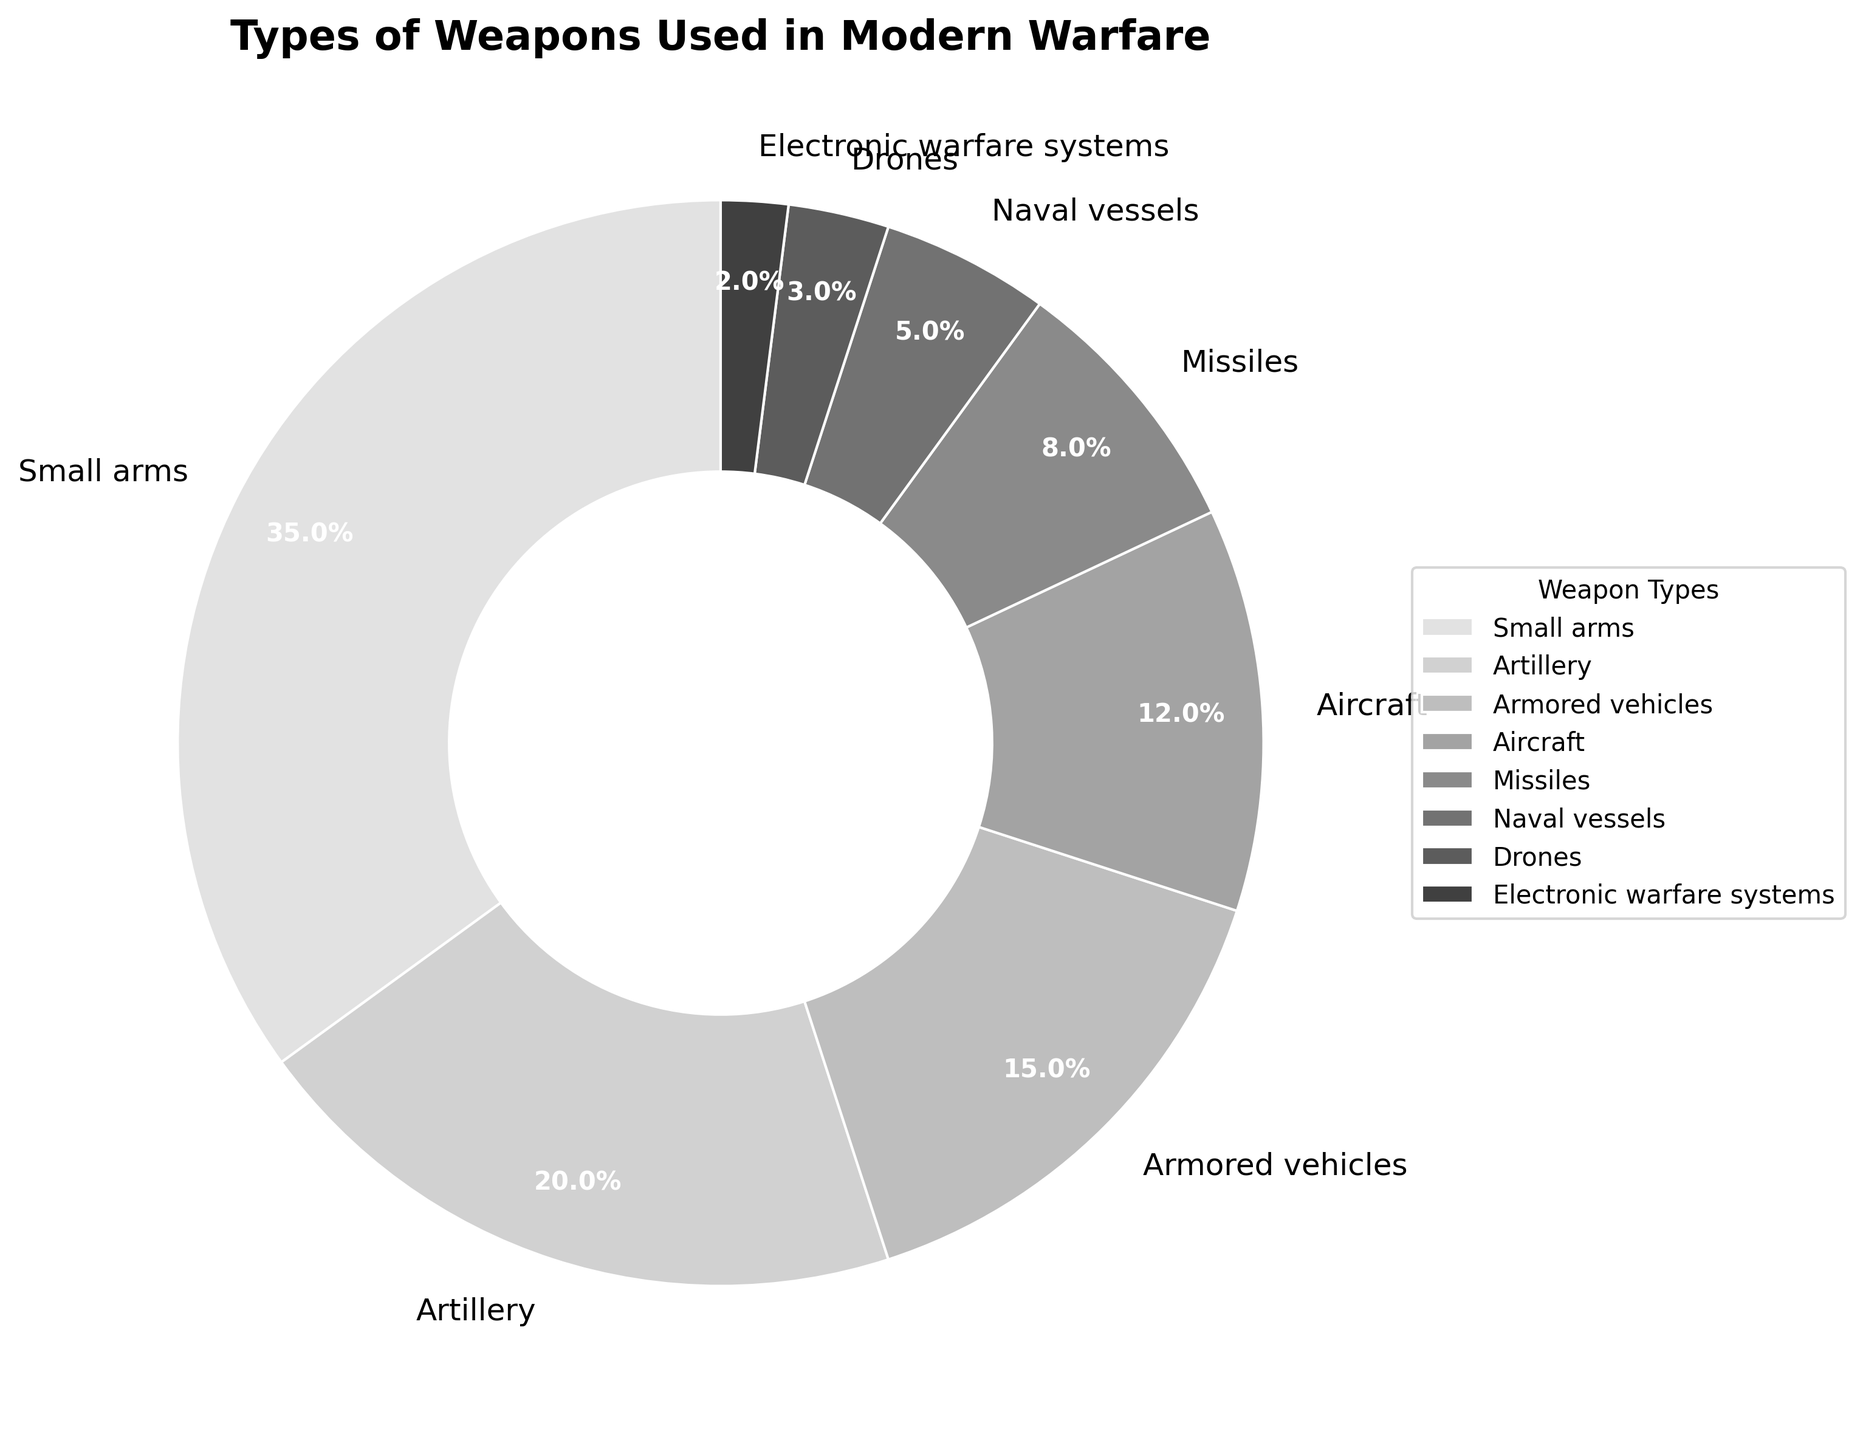What is the category with the highest percentage? The pie chart shows the weapons categories and their corresponding percentages. The segment with the highest percentage is clearly "Small arms," which is labeled and highlights 35%.
Answer: Small arms How much more percentage do Small arms have compared to Missiles? Compare the percentages for Small arms (35%) and Missiles (8%) by subtracting the smaller percentage from the larger one: 35 - 8 = 27.
Answer: 27 Which weapon category is represented by the smallest segment in the pie chart? Looking at the pie chart, the smallest segment is the one labeled "Electronic warfare systems," which shows a percentage of 2%.
Answer: Electronic warfare systems What is the combined percentage of Naval vessels and Drones? Add the percentages for Naval vessels (5%) and Drones (3%) together to find the combined percentage: 5 + 3 = 8.
Answer: 8 Are the combined percentages of Armored vehicles and Aircraft greater than Small arms? First, add the percentages of Armored vehicles (15%) and Aircraft (12%): 15 + 12 = 27. Then compare this to the percentage of Small arms (35%): 27 is less than 35, so they are not greater.
Answer: No What is the total percentage of Small arms, Artillery, and Armored vehicles combined? Add the percentages of Small arms (35%), Artillery (20%), and Armored vehicles (15%): 35 + 20 + 15 = 70.
Answer: 70 Which two categories have a combined percentage equal to 20%? Look for two categories whose percentages add up to 20%. These are Drones (3%) and Naval vessels (5%), which sum to 3 + 5 = 8, and Electronic warfare systems (2%) and Missiles (8%), which sum to 2 + 8 = 10. Neither sets sum to 20%. So, check again - two categories "Artillery" (20%) alone equals 20%. No two categories combined equal 20%.
Answer: None match exactly What percentage of weapons does the combination of Drones, Electronic warfare systems, and Missiles represent? Add the percentages of Drones (3%), Electronic warfare systems (2%), and Missiles (8%): 3 + 2 + 8 = 13.
Answer: 13 Compare the percentage difference between Artillery and Armored vehicles. Subtract the percentage for Armored vehicles (15%) from the percentage for Artillery (20%): 20 - 15 = 5.
Answer: 5 